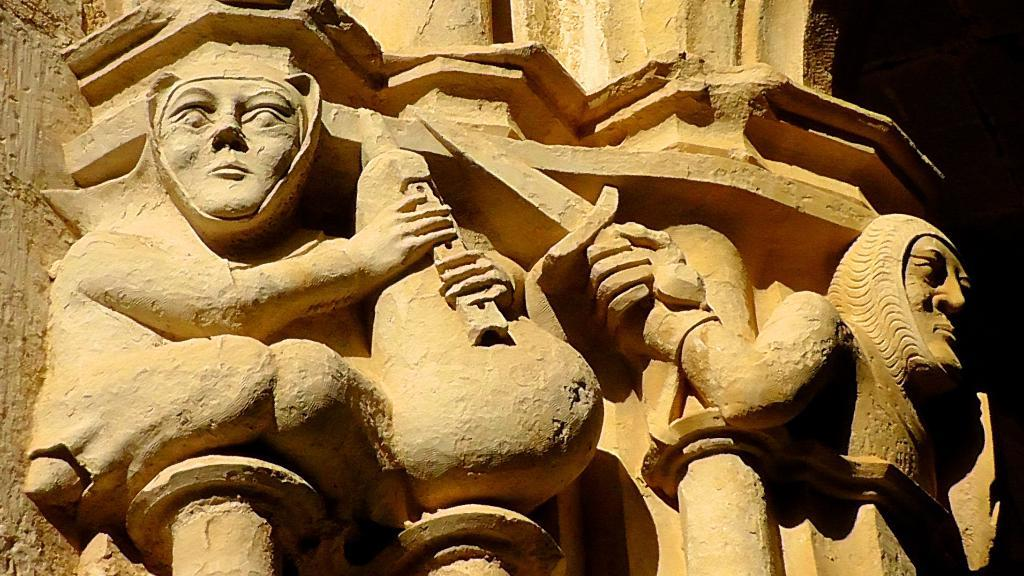What can be seen on the wall in the image? There is stone carving on the wall in the image. What is the color of the background in the image? The background of the image is dark. How many bottles are visible on the wall in the image? There are no bottles visible on the wall in the image; it features stone carving. What type of lumber is used in the construction of the wall in the image? The image does not provide information about the construction of the wall, so it is not possible to determine the type of lumber used. 